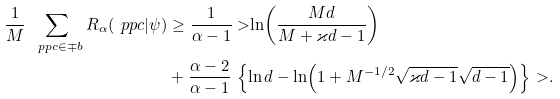Convert formula to latex. <formula><loc_0><loc_0><loc_500><loc_500>\frac { 1 } { M } { \, } \sum _ { \ p p c \in \mp b } R _ { \alpha } ( \ p p c | \psi ) & \geq \frac { 1 } { \alpha - 1 } { \ > } { \ln } { \left ( \frac { M d } { M + \varkappa { d } - 1 } \right ) } \\ & + \frac { \alpha - 2 } { \alpha - 1 } { \, } \left \{ \ln { d } - { \ln } { \left ( 1 + M ^ { - 1 / 2 } \sqrt { \varkappa { d } - 1 } \sqrt { d - 1 } \right ) } \right \} { \ > } .</formula> 